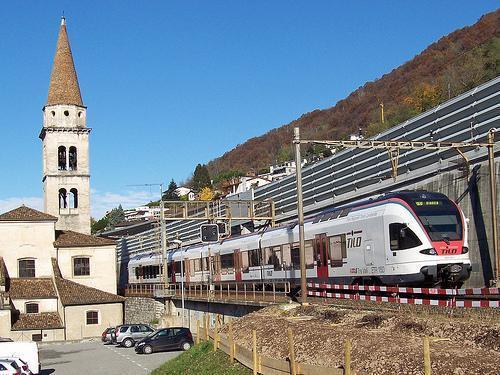How many trains are in this picture?
Give a very brief answer. 1. How many vehicles in the image move on rails?
Give a very brief answer. 1. 